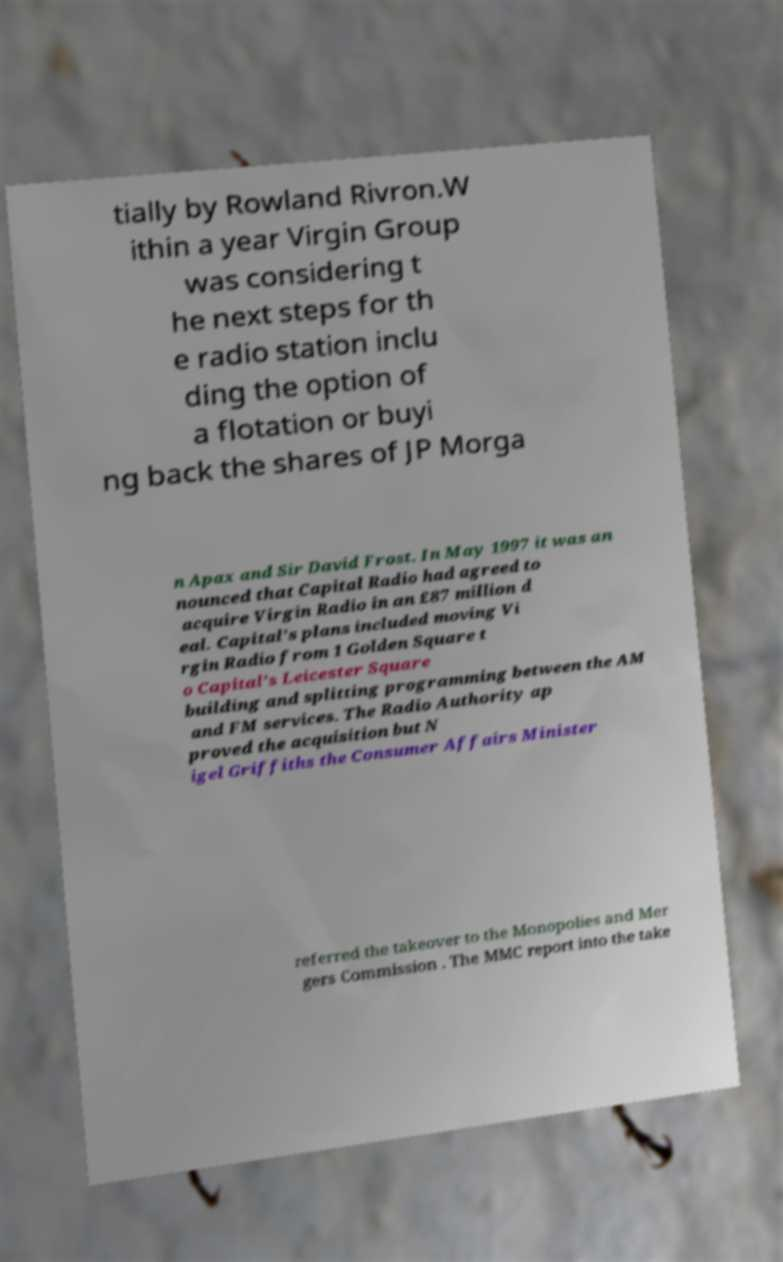Could you extract and type out the text from this image? tially by Rowland Rivron.W ithin a year Virgin Group was considering t he next steps for th e radio station inclu ding the option of a flotation or buyi ng back the shares of JP Morga n Apax and Sir David Frost. In May 1997 it was an nounced that Capital Radio had agreed to acquire Virgin Radio in an £87 million d eal. Capital's plans included moving Vi rgin Radio from 1 Golden Square t o Capital's Leicester Square building and splitting programming between the AM and FM services. The Radio Authority ap proved the acquisition but N igel Griffiths the Consumer Affairs Minister referred the takeover to the Monopolies and Mer gers Commission . The MMC report into the take 